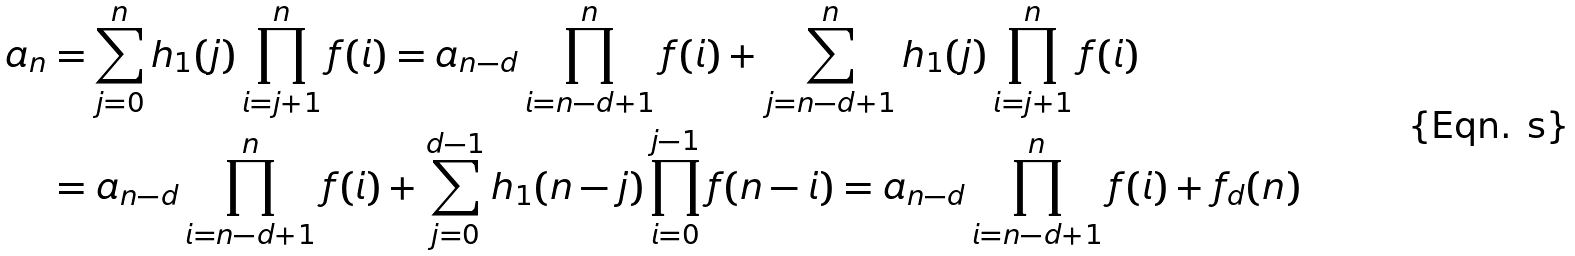<formula> <loc_0><loc_0><loc_500><loc_500>a _ { n } & = \sum _ { j = 0 } ^ { n } h _ { 1 } ( j ) \prod _ { i = j + 1 } ^ { n } f ( i ) = a _ { n - d } \prod _ { i = n - d + 1 } ^ { n } f ( i ) + \sum _ { j = n - d + 1 } ^ { n } h _ { 1 } ( j ) \prod _ { i = j + 1 } ^ { n } f ( i ) \\ & = a _ { n - d } \prod _ { i = n - d + 1 } ^ { n } f ( i ) + \sum _ { j = 0 } ^ { d - 1 } h _ { 1 } ( n - j ) \prod _ { i = 0 } ^ { j - 1 } f ( n - i ) = a _ { n - d } \prod _ { i = n - d + 1 } ^ { n } f ( i ) + f _ { d } ( n )</formula> 